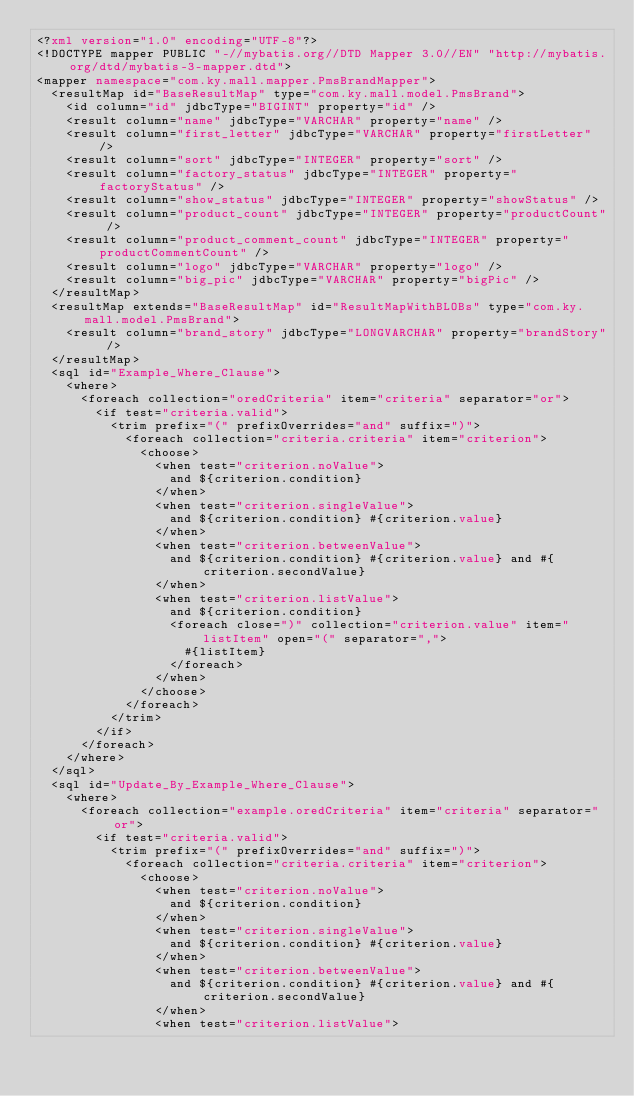<code> <loc_0><loc_0><loc_500><loc_500><_XML_><?xml version="1.0" encoding="UTF-8"?>
<!DOCTYPE mapper PUBLIC "-//mybatis.org//DTD Mapper 3.0//EN" "http://mybatis.org/dtd/mybatis-3-mapper.dtd">
<mapper namespace="com.ky.mall.mapper.PmsBrandMapper">
  <resultMap id="BaseResultMap" type="com.ky.mall.model.PmsBrand">
    <id column="id" jdbcType="BIGINT" property="id" />
    <result column="name" jdbcType="VARCHAR" property="name" />
    <result column="first_letter" jdbcType="VARCHAR" property="firstLetter" />
    <result column="sort" jdbcType="INTEGER" property="sort" />
    <result column="factory_status" jdbcType="INTEGER" property="factoryStatus" />
    <result column="show_status" jdbcType="INTEGER" property="showStatus" />
    <result column="product_count" jdbcType="INTEGER" property="productCount" />
    <result column="product_comment_count" jdbcType="INTEGER" property="productCommentCount" />
    <result column="logo" jdbcType="VARCHAR" property="logo" />
    <result column="big_pic" jdbcType="VARCHAR" property="bigPic" />
  </resultMap>
  <resultMap extends="BaseResultMap" id="ResultMapWithBLOBs" type="com.ky.mall.model.PmsBrand">
    <result column="brand_story" jdbcType="LONGVARCHAR" property="brandStory" />
  </resultMap>
  <sql id="Example_Where_Clause">
    <where>
      <foreach collection="oredCriteria" item="criteria" separator="or">
        <if test="criteria.valid">
          <trim prefix="(" prefixOverrides="and" suffix=")">
            <foreach collection="criteria.criteria" item="criterion">
              <choose>
                <when test="criterion.noValue">
                  and ${criterion.condition}
                </when>
                <when test="criterion.singleValue">
                  and ${criterion.condition} #{criterion.value}
                </when>
                <when test="criterion.betweenValue">
                  and ${criterion.condition} #{criterion.value} and #{criterion.secondValue}
                </when>
                <when test="criterion.listValue">
                  and ${criterion.condition}
                  <foreach close=")" collection="criterion.value" item="listItem" open="(" separator=",">
                    #{listItem}
                  </foreach>
                </when>
              </choose>
            </foreach>
          </trim>
        </if>
      </foreach>
    </where>
  </sql>
  <sql id="Update_By_Example_Where_Clause">
    <where>
      <foreach collection="example.oredCriteria" item="criteria" separator="or">
        <if test="criteria.valid">
          <trim prefix="(" prefixOverrides="and" suffix=")">
            <foreach collection="criteria.criteria" item="criterion">
              <choose>
                <when test="criterion.noValue">
                  and ${criterion.condition}
                </when>
                <when test="criterion.singleValue">
                  and ${criterion.condition} #{criterion.value}
                </when>
                <when test="criterion.betweenValue">
                  and ${criterion.condition} #{criterion.value} and #{criterion.secondValue}
                </when>
                <when test="criterion.listValue"></code> 